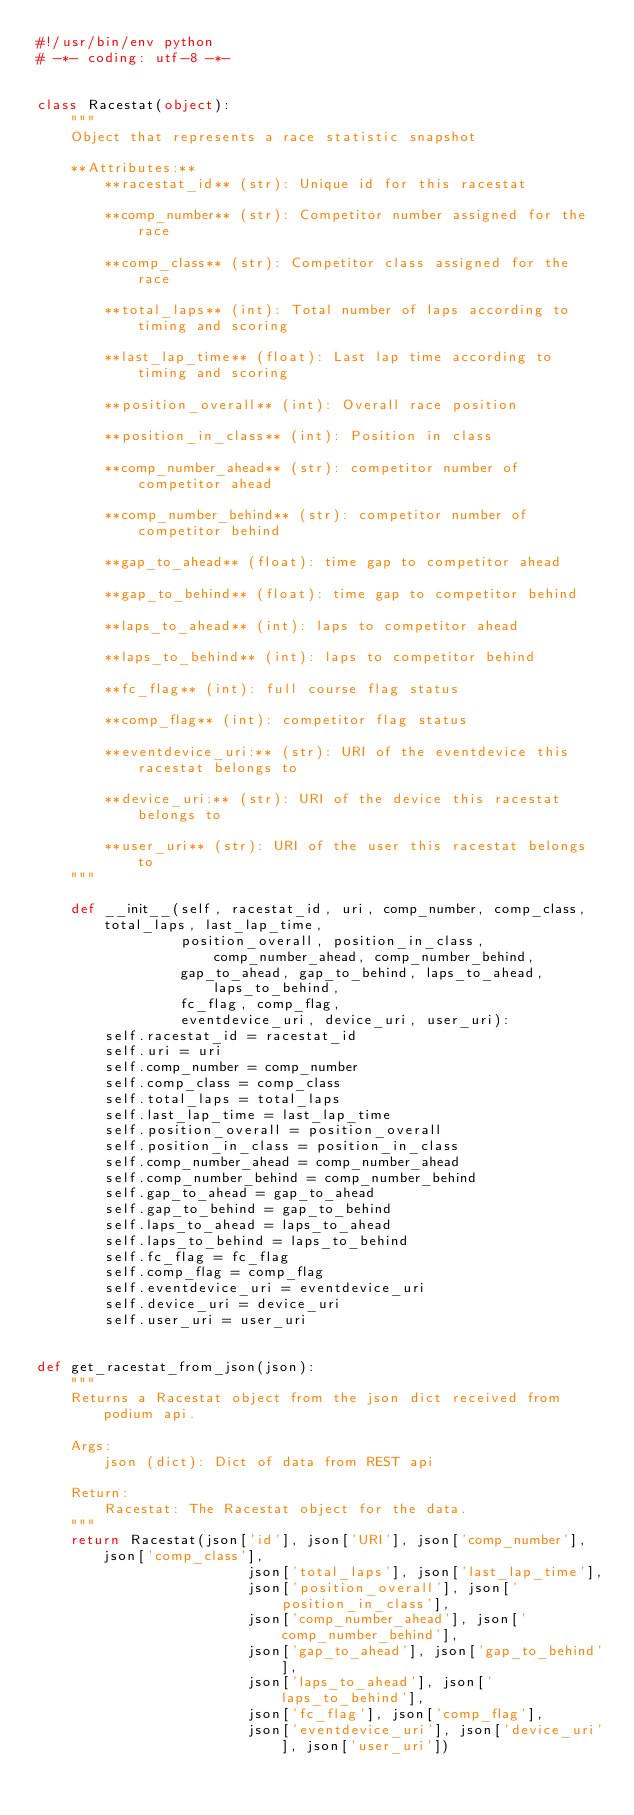<code> <loc_0><loc_0><loc_500><loc_500><_Python_>#!/usr/bin/env python
# -*- coding: utf-8 -*-


class Racestat(object):
    """
    Object that represents a race statistic snapshot

    **Attributes:**
        **racestat_id** (str): Unique id for this racestat

        **comp_number** (str): Competitor number assigned for the race

        **comp_class** (str): Competitor class assigned for the race

        **total_laps** (int): Total number of laps according to timing and scoring

        **last_lap_time** (float): Last lap time according to timing and scoring

        **position_overall** (int): Overall race position

        **position_in_class** (int): Position in class

        **comp_number_ahead** (str): competitor number of competitor ahead
        
        **comp_number_behind** (str): competitor number of competitor behind
        
        **gap_to_ahead** (float): time gap to competitor ahead
        
        **gap_to_behind** (float): time gap to competitor behind
        
        **laps_to_ahead** (int): laps to competitor ahead
        
        **laps_to_behind** (int): laps to competitor behind
        
        **fc_flag** (int): full course flag status
        
        **comp_flag** (int): competitor flag status
        
        **eventdevice_uri:** (str): URI of the eventdevice this racestat belongs to
        
        **device_uri:** (str): URI of the device this racestat belongs to
        
        **user_uri** (str): URI of the user this racestat belongs to        
    """

    def __init__(self, racestat_id, uri, comp_number, comp_class, total_laps, last_lap_time,
                 position_overall, position_in_class, comp_number_ahead, comp_number_behind,
                 gap_to_ahead, gap_to_behind, laps_to_ahead, laps_to_behind,
                 fc_flag, comp_flag,
                 eventdevice_uri, device_uri, user_uri):
        self.racestat_id = racestat_id
        self.uri = uri
        self.comp_number = comp_number
        self.comp_class = comp_class
        self.total_laps = total_laps
        self.last_lap_time = last_lap_time
        self.position_overall = position_overall
        self.position_in_class = position_in_class
        self.comp_number_ahead = comp_number_ahead
        self.comp_number_behind = comp_number_behind
        self.gap_to_ahead = gap_to_ahead
        self.gap_to_behind = gap_to_behind
        self.laps_to_ahead = laps_to_ahead
        self.laps_to_behind = laps_to_behind
        self.fc_flag = fc_flag
        self.comp_flag = comp_flag
        self.eventdevice_uri = eventdevice_uri
        self.device_uri = device_uri
        self.user_uri = user_uri


def get_racestat_from_json(json):
    """
    Returns a Racestat object from the json dict received from podium api.

    Args:
        json (dict): Dict of data from REST api

    Return:
        Racestat: The Racestat object for the data.
    """
    return Racestat(json['id'], json['URI'], json['comp_number'], json['comp_class'],
                         json['total_laps'], json['last_lap_time'],
                         json['position_overall'], json['position_in_class'],
                         json['comp_number_ahead'], json['comp_number_behind'],
                         json['gap_to_ahead'], json['gap_to_behind'],
                         json['laps_to_ahead'], json['laps_to_behind'],
                         json['fc_flag'], json['comp_flag'],
                         json['eventdevice_uri'], json['device_uri'], json['user_uri'])
</code> 